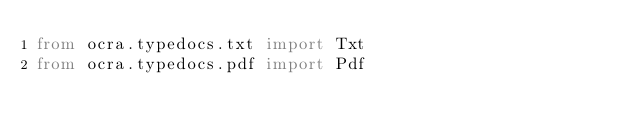Convert code to text. <code><loc_0><loc_0><loc_500><loc_500><_Python_>from ocra.typedocs.txt import Txt
from ocra.typedocs.pdf import Pdf

</code> 